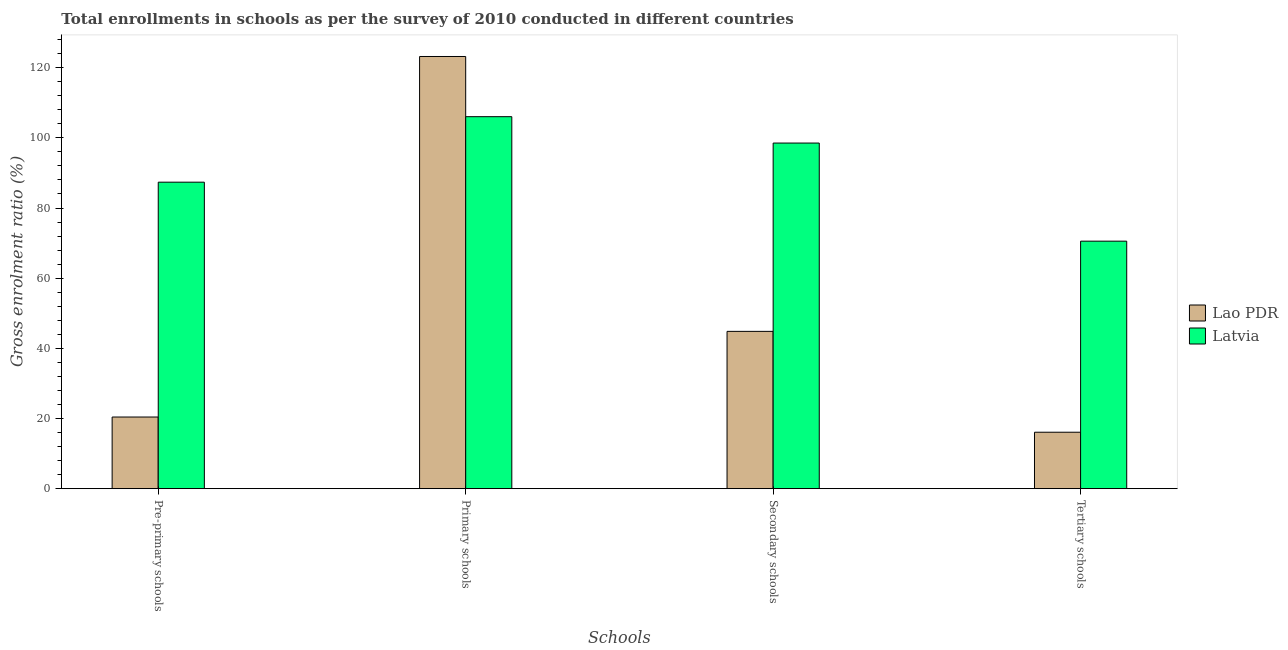How many different coloured bars are there?
Give a very brief answer. 2. Are the number of bars per tick equal to the number of legend labels?
Provide a succinct answer. Yes. How many bars are there on the 2nd tick from the right?
Provide a succinct answer. 2. What is the label of the 3rd group of bars from the left?
Keep it short and to the point. Secondary schools. What is the gross enrolment ratio in primary schools in Lao PDR?
Offer a terse response. 123.19. Across all countries, what is the maximum gross enrolment ratio in tertiary schools?
Ensure brevity in your answer.  70.55. Across all countries, what is the minimum gross enrolment ratio in secondary schools?
Keep it short and to the point. 44.84. In which country was the gross enrolment ratio in primary schools maximum?
Provide a short and direct response. Lao PDR. In which country was the gross enrolment ratio in pre-primary schools minimum?
Provide a succinct answer. Lao PDR. What is the total gross enrolment ratio in tertiary schools in the graph?
Make the answer very short. 86.64. What is the difference between the gross enrolment ratio in pre-primary schools in Latvia and that in Lao PDR?
Your answer should be very brief. 66.94. What is the difference between the gross enrolment ratio in pre-primary schools in Lao PDR and the gross enrolment ratio in secondary schools in Latvia?
Your answer should be compact. -78.09. What is the average gross enrolment ratio in secondary schools per country?
Your response must be concise. 71.68. What is the difference between the gross enrolment ratio in pre-primary schools and gross enrolment ratio in tertiary schools in Lao PDR?
Provide a short and direct response. 4.34. What is the ratio of the gross enrolment ratio in tertiary schools in Latvia to that in Lao PDR?
Your answer should be compact. 4.39. Is the gross enrolment ratio in pre-primary schools in Latvia less than that in Lao PDR?
Offer a terse response. No. What is the difference between the highest and the second highest gross enrolment ratio in secondary schools?
Your answer should be compact. 53.67. What is the difference between the highest and the lowest gross enrolment ratio in pre-primary schools?
Keep it short and to the point. 66.94. Is the sum of the gross enrolment ratio in secondary schools in Lao PDR and Latvia greater than the maximum gross enrolment ratio in primary schools across all countries?
Provide a short and direct response. Yes. Is it the case that in every country, the sum of the gross enrolment ratio in primary schools and gross enrolment ratio in secondary schools is greater than the sum of gross enrolment ratio in tertiary schools and gross enrolment ratio in pre-primary schools?
Your response must be concise. Yes. What does the 1st bar from the left in Primary schools represents?
Your answer should be compact. Lao PDR. What does the 1st bar from the right in Primary schools represents?
Ensure brevity in your answer.  Latvia. Is it the case that in every country, the sum of the gross enrolment ratio in pre-primary schools and gross enrolment ratio in primary schools is greater than the gross enrolment ratio in secondary schools?
Your response must be concise. Yes. Are all the bars in the graph horizontal?
Offer a terse response. No. What is the difference between two consecutive major ticks on the Y-axis?
Provide a succinct answer. 20. Does the graph contain any zero values?
Offer a terse response. No. Does the graph contain grids?
Provide a succinct answer. No. Where does the legend appear in the graph?
Offer a very short reply. Center right. How many legend labels are there?
Make the answer very short. 2. How are the legend labels stacked?
Ensure brevity in your answer.  Vertical. What is the title of the graph?
Keep it short and to the point. Total enrollments in schools as per the survey of 2010 conducted in different countries. Does "Cayman Islands" appear as one of the legend labels in the graph?
Offer a very short reply. No. What is the label or title of the X-axis?
Offer a very short reply. Schools. What is the label or title of the Y-axis?
Your answer should be compact. Gross enrolment ratio (%). What is the Gross enrolment ratio (%) in Lao PDR in Pre-primary schools?
Give a very brief answer. 20.42. What is the Gross enrolment ratio (%) in Latvia in Pre-primary schools?
Your answer should be very brief. 87.36. What is the Gross enrolment ratio (%) of Lao PDR in Primary schools?
Offer a very short reply. 123.19. What is the Gross enrolment ratio (%) of Latvia in Primary schools?
Your answer should be compact. 106.03. What is the Gross enrolment ratio (%) in Lao PDR in Secondary schools?
Provide a short and direct response. 44.84. What is the Gross enrolment ratio (%) of Latvia in Secondary schools?
Your answer should be very brief. 98.51. What is the Gross enrolment ratio (%) of Lao PDR in Tertiary schools?
Ensure brevity in your answer.  16.09. What is the Gross enrolment ratio (%) in Latvia in Tertiary schools?
Your response must be concise. 70.55. Across all Schools, what is the maximum Gross enrolment ratio (%) of Lao PDR?
Ensure brevity in your answer.  123.19. Across all Schools, what is the maximum Gross enrolment ratio (%) of Latvia?
Offer a very short reply. 106.03. Across all Schools, what is the minimum Gross enrolment ratio (%) in Lao PDR?
Provide a succinct answer. 16.09. Across all Schools, what is the minimum Gross enrolment ratio (%) in Latvia?
Your answer should be very brief. 70.55. What is the total Gross enrolment ratio (%) in Lao PDR in the graph?
Offer a very short reply. 204.54. What is the total Gross enrolment ratio (%) in Latvia in the graph?
Your answer should be compact. 362.46. What is the difference between the Gross enrolment ratio (%) in Lao PDR in Pre-primary schools and that in Primary schools?
Make the answer very short. -102.77. What is the difference between the Gross enrolment ratio (%) in Latvia in Pre-primary schools and that in Primary schools?
Offer a terse response. -18.67. What is the difference between the Gross enrolment ratio (%) of Lao PDR in Pre-primary schools and that in Secondary schools?
Your answer should be compact. -24.42. What is the difference between the Gross enrolment ratio (%) in Latvia in Pre-primary schools and that in Secondary schools?
Offer a very short reply. -11.15. What is the difference between the Gross enrolment ratio (%) of Lao PDR in Pre-primary schools and that in Tertiary schools?
Offer a very short reply. 4.34. What is the difference between the Gross enrolment ratio (%) of Latvia in Pre-primary schools and that in Tertiary schools?
Ensure brevity in your answer.  16.81. What is the difference between the Gross enrolment ratio (%) of Lao PDR in Primary schools and that in Secondary schools?
Your response must be concise. 78.35. What is the difference between the Gross enrolment ratio (%) in Latvia in Primary schools and that in Secondary schools?
Make the answer very short. 7.52. What is the difference between the Gross enrolment ratio (%) in Lao PDR in Primary schools and that in Tertiary schools?
Make the answer very short. 107.1. What is the difference between the Gross enrolment ratio (%) of Latvia in Primary schools and that in Tertiary schools?
Provide a succinct answer. 35.48. What is the difference between the Gross enrolment ratio (%) of Lao PDR in Secondary schools and that in Tertiary schools?
Make the answer very short. 28.75. What is the difference between the Gross enrolment ratio (%) in Latvia in Secondary schools and that in Tertiary schools?
Your answer should be very brief. 27.96. What is the difference between the Gross enrolment ratio (%) in Lao PDR in Pre-primary schools and the Gross enrolment ratio (%) in Latvia in Primary schools?
Keep it short and to the point. -85.61. What is the difference between the Gross enrolment ratio (%) in Lao PDR in Pre-primary schools and the Gross enrolment ratio (%) in Latvia in Secondary schools?
Keep it short and to the point. -78.09. What is the difference between the Gross enrolment ratio (%) of Lao PDR in Pre-primary schools and the Gross enrolment ratio (%) of Latvia in Tertiary schools?
Make the answer very short. -50.13. What is the difference between the Gross enrolment ratio (%) of Lao PDR in Primary schools and the Gross enrolment ratio (%) of Latvia in Secondary schools?
Your answer should be very brief. 24.68. What is the difference between the Gross enrolment ratio (%) in Lao PDR in Primary schools and the Gross enrolment ratio (%) in Latvia in Tertiary schools?
Give a very brief answer. 52.64. What is the difference between the Gross enrolment ratio (%) of Lao PDR in Secondary schools and the Gross enrolment ratio (%) of Latvia in Tertiary schools?
Offer a very short reply. -25.71. What is the average Gross enrolment ratio (%) of Lao PDR per Schools?
Your response must be concise. 51.14. What is the average Gross enrolment ratio (%) in Latvia per Schools?
Offer a very short reply. 90.61. What is the difference between the Gross enrolment ratio (%) of Lao PDR and Gross enrolment ratio (%) of Latvia in Pre-primary schools?
Offer a very short reply. -66.94. What is the difference between the Gross enrolment ratio (%) of Lao PDR and Gross enrolment ratio (%) of Latvia in Primary schools?
Give a very brief answer. 17.16. What is the difference between the Gross enrolment ratio (%) of Lao PDR and Gross enrolment ratio (%) of Latvia in Secondary schools?
Keep it short and to the point. -53.67. What is the difference between the Gross enrolment ratio (%) in Lao PDR and Gross enrolment ratio (%) in Latvia in Tertiary schools?
Ensure brevity in your answer.  -54.46. What is the ratio of the Gross enrolment ratio (%) of Lao PDR in Pre-primary schools to that in Primary schools?
Provide a short and direct response. 0.17. What is the ratio of the Gross enrolment ratio (%) in Latvia in Pre-primary schools to that in Primary schools?
Make the answer very short. 0.82. What is the ratio of the Gross enrolment ratio (%) in Lao PDR in Pre-primary schools to that in Secondary schools?
Offer a terse response. 0.46. What is the ratio of the Gross enrolment ratio (%) of Latvia in Pre-primary schools to that in Secondary schools?
Make the answer very short. 0.89. What is the ratio of the Gross enrolment ratio (%) in Lao PDR in Pre-primary schools to that in Tertiary schools?
Offer a very short reply. 1.27. What is the ratio of the Gross enrolment ratio (%) of Latvia in Pre-primary schools to that in Tertiary schools?
Your response must be concise. 1.24. What is the ratio of the Gross enrolment ratio (%) in Lao PDR in Primary schools to that in Secondary schools?
Your response must be concise. 2.75. What is the ratio of the Gross enrolment ratio (%) of Latvia in Primary schools to that in Secondary schools?
Keep it short and to the point. 1.08. What is the ratio of the Gross enrolment ratio (%) in Lao PDR in Primary schools to that in Tertiary schools?
Your response must be concise. 7.66. What is the ratio of the Gross enrolment ratio (%) of Latvia in Primary schools to that in Tertiary schools?
Make the answer very short. 1.5. What is the ratio of the Gross enrolment ratio (%) of Lao PDR in Secondary schools to that in Tertiary schools?
Your answer should be compact. 2.79. What is the ratio of the Gross enrolment ratio (%) in Latvia in Secondary schools to that in Tertiary schools?
Your answer should be very brief. 1.4. What is the difference between the highest and the second highest Gross enrolment ratio (%) in Lao PDR?
Give a very brief answer. 78.35. What is the difference between the highest and the second highest Gross enrolment ratio (%) in Latvia?
Provide a succinct answer. 7.52. What is the difference between the highest and the lowest Gross enrolment ratio (%) in Lao PDR?
Make the answer very short. 107.1. What is the difference between the highest and the lowest Gross enrolment ratio (%) of Latvia?
Ensure brevity in your answer.  35.48. 